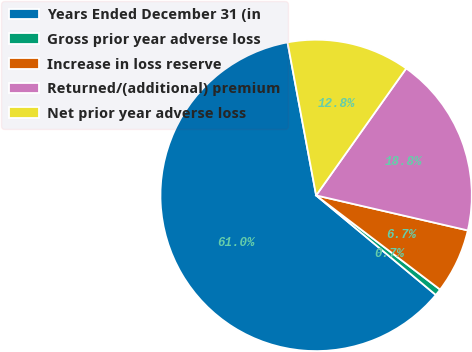Convert chart to OTSL. <chart><loc_0><loc_0><loc_500><loc_500><pie_chart><fcel>Years Ended December 31 (in<fcel>Gross prior year adverse loss<fcel>Increase in loss reserve<fcel>Returned/(additional) premium<fcel>Net prior year adverse loss<nl><fcel>61.01%<fcel>0.7%<fcel>6.73%<fcel>18.79%<fcel>12.76%<nl></chart> 